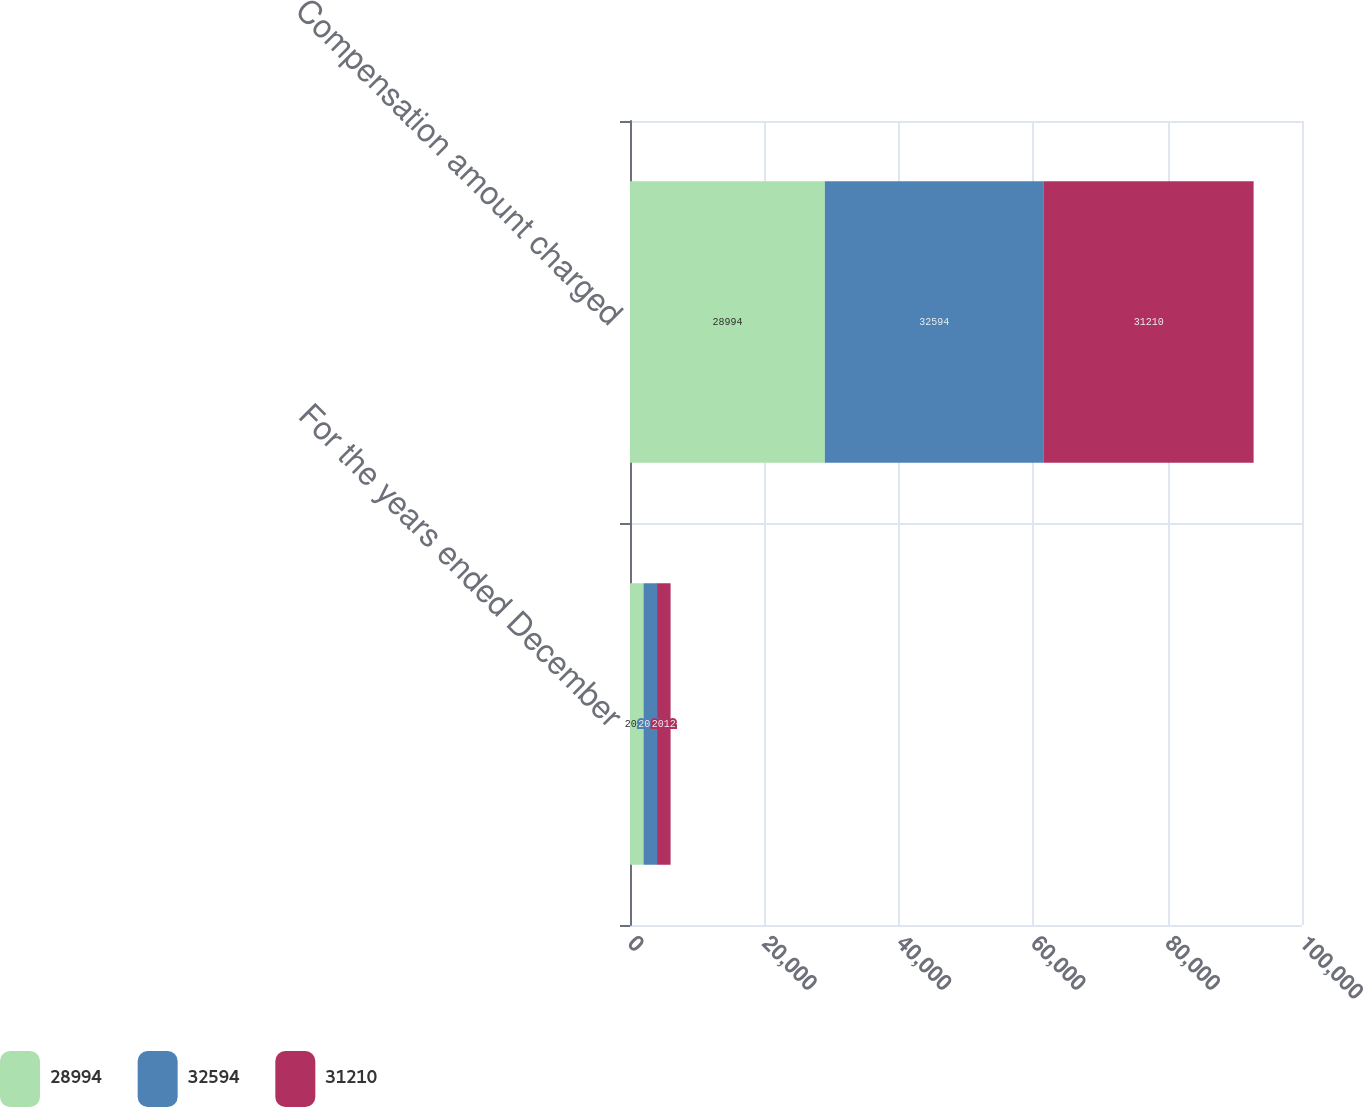<chart> <loc_0><loc_0><loc_500><loc_500><stacked_bar_chart><ecel><fcel>For the years ended December<fcel>Compensation amount charged<nl><fcel>28994<fcel>2014<fcel>28994<nl><fcel>32594<fcel>2013<fcel>32594<nl><fcel>31210<fcel>2012<fcel>31210<nl></chart> 